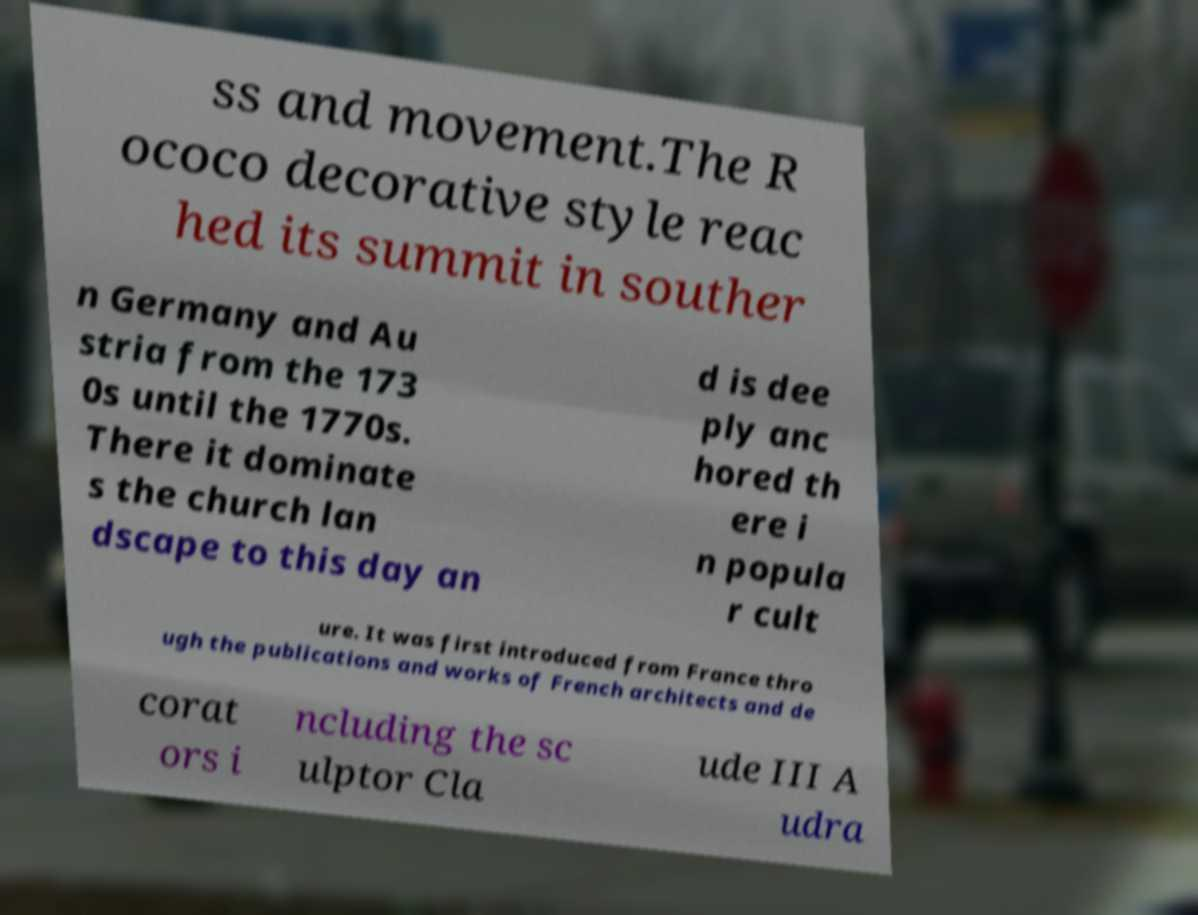Could you assist in decoding the text presented in this image and type it out clearly? ss and movement.The R ococo decorative style reac hed its summit in souther n Germany and Au stria from the 173 0s until the 1770s. There it dominate s the church lan dscape to this day an d is dee ply anc hored th ere i n popula r cult ure. It was first introduced from France thro ugh the publications and works of French architects and de corat ors i ncluding the sc ulptor Cla ude III A udra 